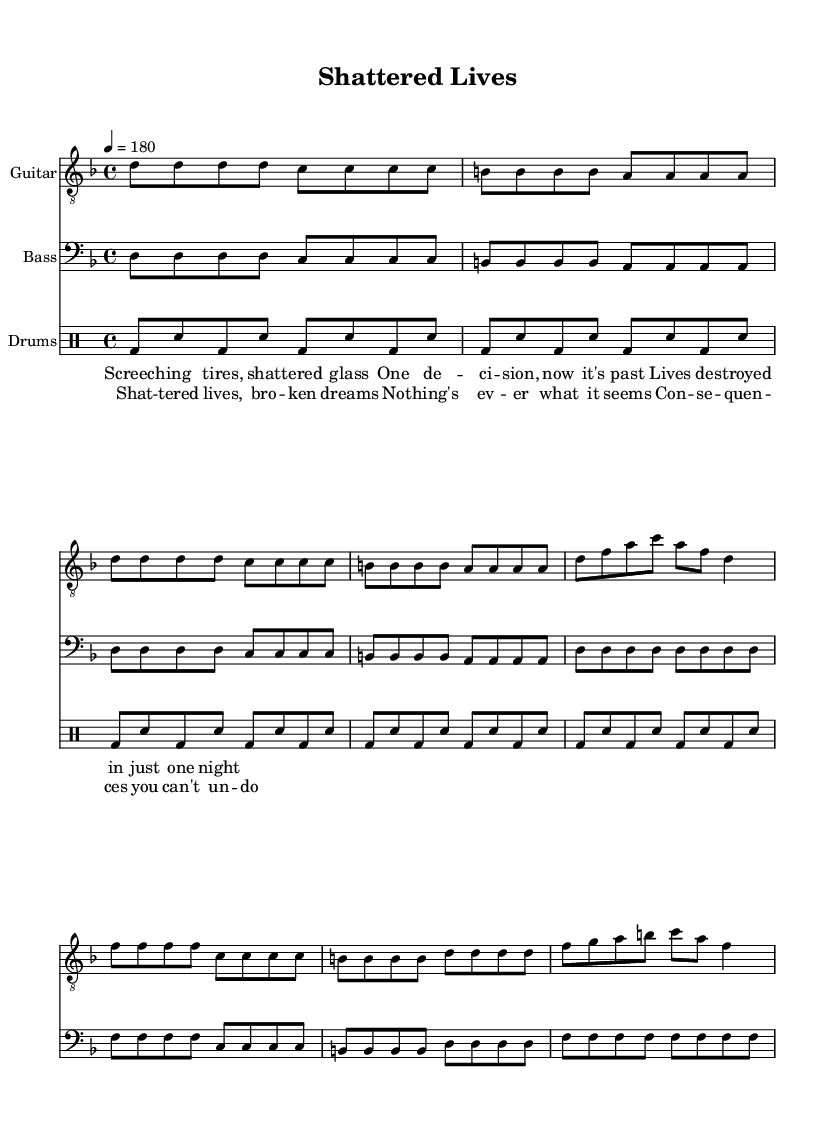What is the key signature of this music? The key signature is D minor, which includes one flat (B♭). This can be determined by looking at the key signature indicated at the beginning of the sheet music.
Answer: D minor What is the time signature of this music? The time signature is 4/4, meaning there are four beats in each measure, and the quarter note gets one beat. This is specified at the start of the piece.
Answer: 4/4 What is the tempo of the song? The tempo is marked as 180 beats per minute, indicating a fast pace for the music. This is indicated in the tempo marking at the beginning of the score.
Answer: 180 What is the main theme discussed in the lyrics? The main theme addresses the consequences of impaired driving on victims and families, which is evident from phrases like "shattered lives" and "broken dreams" present in the lyrics.
Answer: Consequences of impaired driving How many measures are in the chorus section? The chorus section consists of 4 measures, as indicated by the grouping of the notes and rests. These can be counted in the sheet music as distinct groupings of musical phrases.
Answer: 4 In which section does the lyric "Screeching tires, shattered glass" appear? This lyric appears in the verse section, which can be discerned from the layout of the lyrics corresponding with the musical notation. The verse is labeled separately in the sheet music.
Answer: Verse 